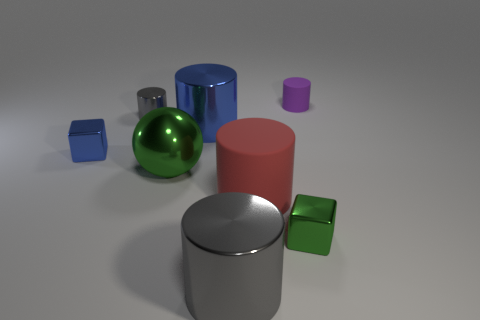How many other objects are there of the same shape as the tiny purple rubber thing?
Provide a short and direct response. 4. Does the tiny cube to the left of the small green shiny thing have the same material as the large cylinder that is behind the red rubber cylinder?
Your answer should be compact. Yes. There is a metal thing that is left of the red matte cylinder and in front of the green metal ball; what shape is it?
Offer a very short reply. Cylinder. There is a thing that is both to the right of the large red cylinder and in front of the large green metal thing; what material is it?
Make the answer very short. Metal. There is a green thing that is the same material as the big sphere; what shape is it?
Your response must be concise. Cube. Are there any other things of the same color as the big rubber object?
Provide a short and direct response. No. Is the number of rubber cylinders that are in front of the small purple matte thing greater than the number of small cyan metal balls?
Your answer should be very brief. Yes. What is the large red object made of?
Provide a succinct answer. Rubber. How many matte cylinders are the same size as the blue block?
Your answer should be compact. 1. Are there the same number of blue cubes in front of the tiny blue shiny object and gray things left of the big metallic ball?
Keep it short and to the point. No. 